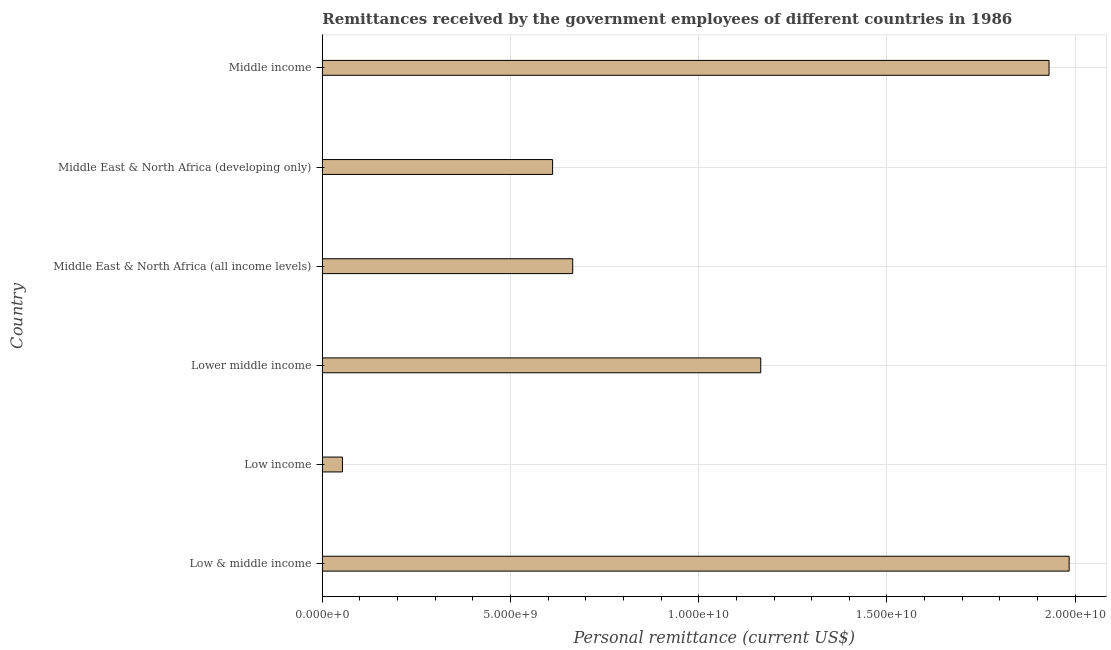Does the graph contain any zero values?
Give a very brief answer. No. What is the title of the graph?
Offer a terse response. Remittances received by the government employees of different countries in 1986. What is the label or title of the X-axis?
Make the answer very short. Personal remittance (current US$). What is the label or title of the Y-axis?
Make the answer very short. Country. What is the personal remittances in Middle East & North Africa (all income levels)?
Make the answer very short. 6.65e+09. Across all countries, what is the maximum personal remittances?
Ensure brevity in your answer.  1.98e+1. Across all countries, what is the minimum personal remittances?
Provide a short and direct response. 5.34e+08. In which country was the personal remittances maximum?
Provide a succinct answer. Low & middle income. What is the sum of the personal remittances?
Offer a very short reply. 6.41e+1. What is the difference between the personal remittances in Low income and Middle East & North Africa (developing only)?
Your answer should be very brief. -5.58e+09. What is the average personal remittances per country?
Give a very brief answer. 1.07e+1. What is the median personal remittances?
Your response must be concise. 9.15e+09. In how many countries, is the personal remittances greater than 2000000000 US$?
Offer a very short reply. 5. What is the ratio of the personal remittances in Low income to that in Lower middle income?
Provide a short and direct response. 0.05. Is the difference between the personal remittances in Low & middle income and Middle East & North Africa (all income levels) greater than the difference between any two countries?
Your response must be concise. No. What is the difference between the highest and the second highest personal remittances?
Make the answer very short. 5.34e+08. Is the sum of the personal remittances in Middle East & North Africa (developing only) and Middle income greater than the maximum personal remittances across all countries?
Keep it short and to the point. Yes. What is the difference between the highest and the lowest personal remittances?
Offer a terse response. 1.93e+1. Are all the bars in the graph horizontal?
Ensure brevity in your answer.  Yes. What is the difference between two consecutive major ticks on the X-axis?
Offer a terse response. 5.00e+09. Are the values on the major ticks of X-axis written in scientific E-notation?
Provide a short and direct response. Yes. What is the Personal remittance (current US$) in Low & middle income?
Offer a terse response. 1.98e+1. What is the Personal remittance (current US$) of Low income?
Provide a short and direct response. 5.34e+08. What is the Personal remittance (current US$) in Lower middle income?
Ensure brevity in your answer.  1.16e+1. What is the Personal remittance (current US$) of Middle East & North Africa (all income levels)?
Offer a terse response. 6.65e+09. What is the Personal remittance (current US$) of Middle East & North Africa (developing only)?
Your answer should be compact. 6.12e+09. What is the Personal remittance (current US$) of Middle income?
Your answer should be very brief. 1.93e+1. What is the difference between the Personal remittance (current US$) in Low & middle income and Low income?
Make the answer very short. 1.93e+1. What is the difference between the Personal remittance (current US$) in Low & middle income and Lower middle income?
Provide a succinct answer. 8.19e+09. What is the difference between the Personal remittance (current US$) in Low & middle income and Middle East & North Africa (all income levels)?
Provide a succinct answer. 1.32e+1. What is the difference between the Personal remittance (current US$) in Low & middle income and Middle East & North Africa (developing only)?
Ensure brevity in your answer.  1.37e+1. What is the difference between the Personal remittance (current US$) in Low & middle income and Middle income?
Offer a terse response. 5.34e+08. What is the difference between the Personal remittance (current US$) in Low income and Lower middle income?
Your answer should be compact. -1.11e+1. What is the difference between the Personal remittance (current US$) in Low income and Middle East & North Africa (all income levels)?
Ensure brevity in your answer.  -6.12e+09. What is the difference between the Personal remittance (current US$) in Low income and Middle East & North Africa (developing only)?
Offer a very short reply. -5.58e+09. What is the difference between the Personal remittance (current US$) in Low income and Middle income?
Ensure brevity in your answer.  -1.88e+1. What is the difference between the Personal remittance (current US$) in Lower middle income and Middle East & North Africa (all income levels)?
Your answer should be very brief. 5.00e+09. What is the difference between the Personal remittance (current US$) in Lower middle income and Middle East & North Africa (developing only)?
Your answer should be very brief. 5.53e+09. What is the difference between the Personal remittance (current US$) in Lower middle income and Middle income?
Offer a very short reply. -7.66e+09. What is the difference between the Personal remittance (current US$) in Middle East & North Africa (all income levels) and Middle East & North Africa (developing only)?
Make the answer very short. 5.34e+08. What is the difference between the Personal remittance (current US$) in Middle East & North Africa (all income levels) and Middle income?
Your answer should be compact. -1.27e+1. What is the difference between the Personal remittance (current US$) in Middle East & North Africa (developing only) and Middle income?
Ensure brevity in your answer.  -1.32e+1. What is the ratio of the Personal remittance (current US$) in Low & middle income to that in Low income?
Give a very brief answer. 37.15. What is the ratio of the Personal remittance (current US$) in Low & middle income to that in Lower middle income?
Keep it short and to the point. 1.7. What is the ratio of the Personal remittance (current US$) in Low & middle income to that in Middle East & North Africa (all income levels)?
Keep it short and to the point. 2.98. What is the ratio of the Personal remittance (current US$) in Low & middle income to that in Middle East & North Africa (developing only)?
Make the answer very short. 3.24. What is the ratio of the Personal remittance (current US$) in Low & middle income to that in Middle income?
Your answer should be compact. 1.03. What is the ratio of the Personal remittance (current US$) in Low income to that in Lower middle income?
Offer a terse response. 0.05. What is the ratio of the Personal remittance (current US$) in Low income to that in Middle East & North Africa (developing only)?
Give a very brief answer. 0.09. What is the ratio of the Personal remittance (current US$) in Low income to that in Middle income?
Ensure brevity in your answer.  0.03. What is the ratio of the Personal remittance (current US$) in Lower middle income to that in Middle East & North Africa (all income levels)?
Provide a succinct answer. 1.75. What is the ratio of the Personal remittance (current US$) in Lower middle income to that in Middle East & North Africa (developing only)?
Provide a succinct answer. 1.9. What is the ratio of the Personal remittance (current US$) in Lower middle income to that in Middle income?
Make the answer very short. 0.6. What is the ratio of the Personal remittance (current US$) in Middle East & North Africa (all income levels) to that in Middle East & North Africa (developing only)?
Provide a succinct answer. 1.09. What is the ratio of the Personal remittance (current US$) in Middle East & North Africa (all income levels) to that in Middle income?
Provide a succinct answer. 0.34. What is the ratio of the Personal remittance (current US$) in Middle East & North Africa (developing only) to that in Middle income?
Keep it short and to the point. 0.32. 